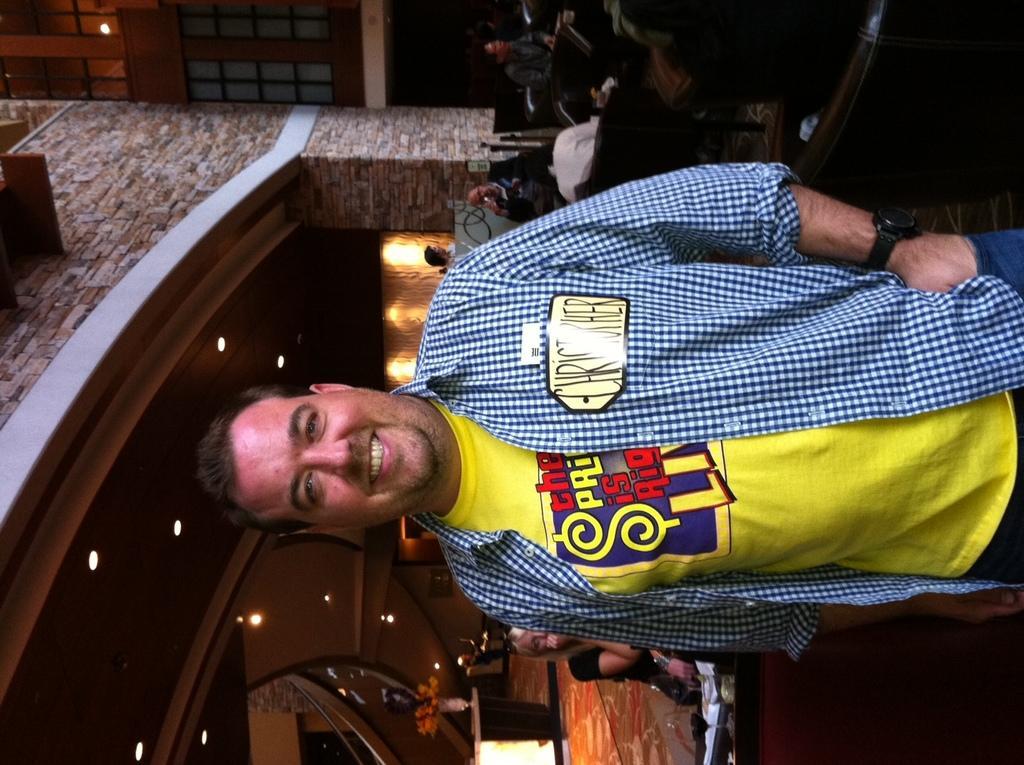How would you summarize this image in a sentence or two? This is the picture of a man in a restaurant. The man is in yellow t shirt with a blue checks shirt. The man wearing a watch to his left hand. There are group of people sitting on the chair. The background of the man is a wall with bricks and with lights and there are glass windows. There is person siting behind the man. 